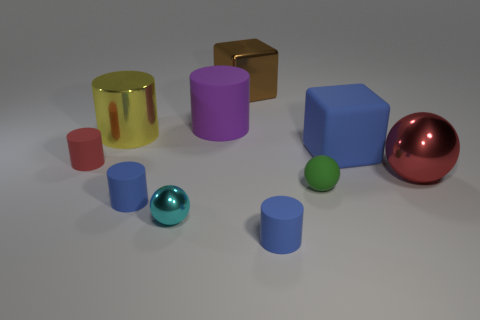What number of metallic things are there?
Offer a very short reply. 4. How many big objects have the same material as the yellow cylinder?
Make the answer very short. 2. What number of objects are either small blue rubber cylinders that are to the left of the cyan metal sphere or big purple cylinders?
Provide a short and direct response. 2. Is the number of small blue rubber cylinders that are to the right of the large sphere less than the number of tiny rubber objects in front of the matte sphere?
Keep it short and to the point. Yes. Are there any small blue objects behind the large red shiny object?
Your answer should be very brief. No. How many things are blue matte things behind the red metal sphere or rubber things that are left of the big brown thing?
Make the answer very short. 4. What number of tiny matte cylinders have the same color as the large shiny sphere?
Give a very brief answer. 1. The tiny matte object that is the same shape as the big red metallic object is what color?
Give a very brief answer. Green. What is the shape of the thing that is both left of the large shiny block and behind the big yellow metal thing?
Keep it short and to the point. Cylinder. Is the number of tiny yellow matte cubes greater than the number of large shiny balls?
Offer a very short reply. No. 